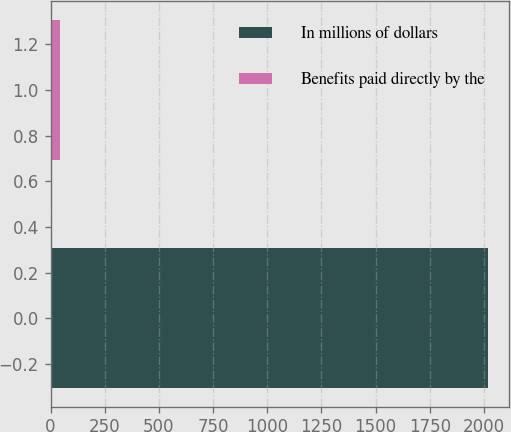Convert chart to OTSL. <chart><loc_0><loc_0><loc_500><loc_500><bar_chart><fcel>In millions of dollars<fcel>Benefits paid directly by the<nl><fcel>2017<fcel>45<nl></chart> 